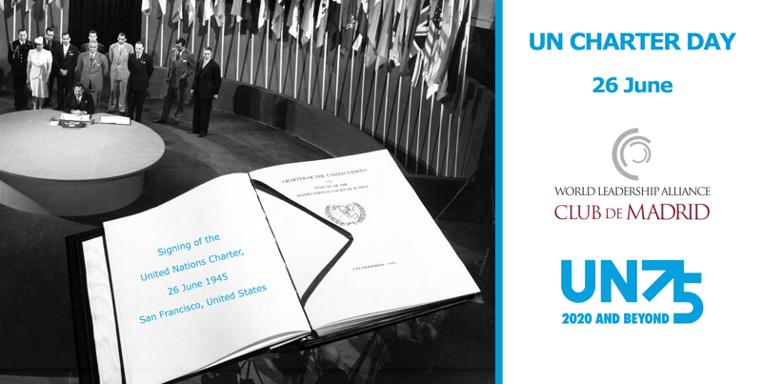What organization is involved in this event, as indicated in the image? The image shows the emblem of the World Leadership Alliance Club de Madrid next to the information about UN Charter Day, suggesting a connection. The Club de Madrid is an independent nonprofit organization composed of over 110 democratic former Presidents and Prime Ministers from more than 60 countries, committed to supporting democratic values and leadership around the world. 